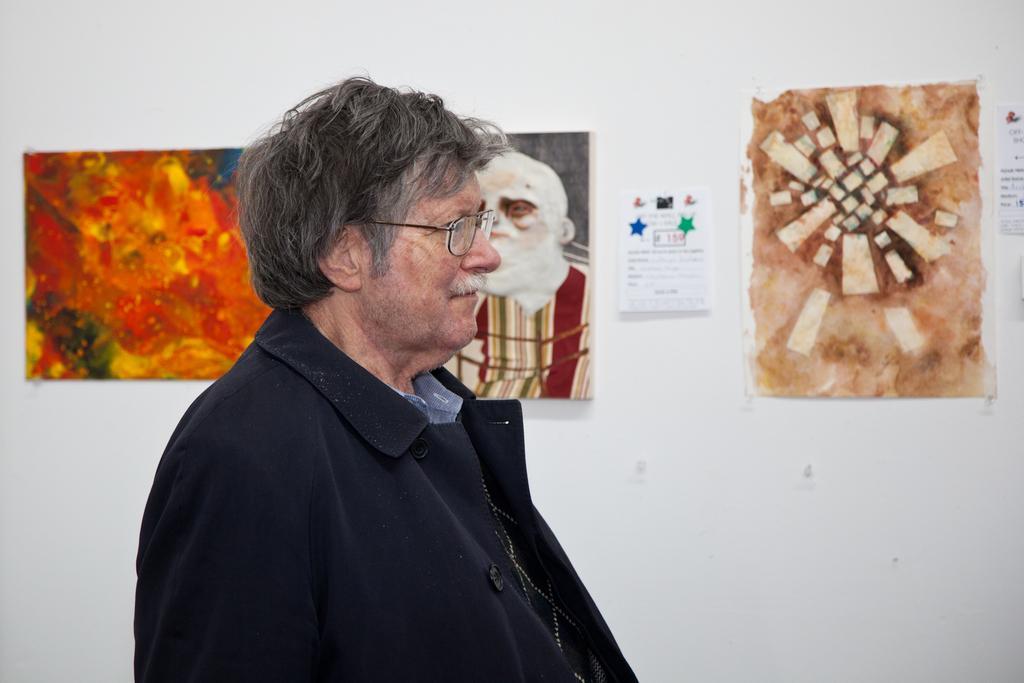Can you describe this image briefly? In this image there is an old man who is wearing the black coat is in the middle. In the background there is a wall to which there are posters and frames. 